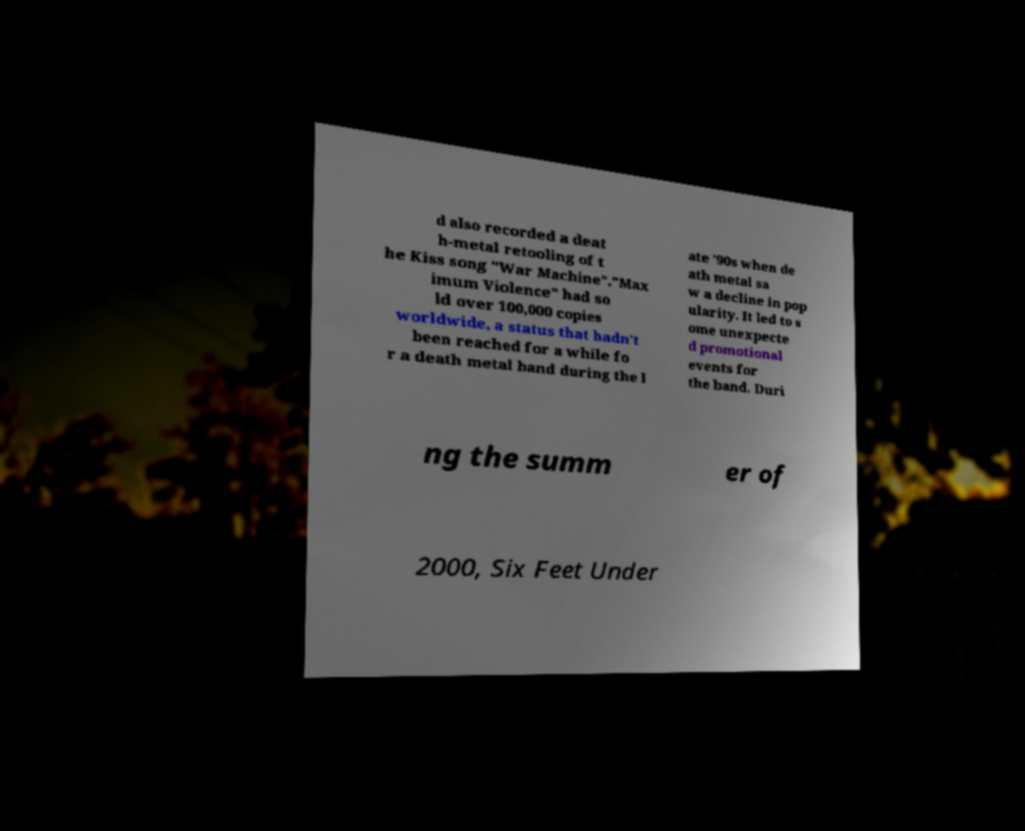What messages or text are displayed in this image? I need them in a readable, typed format. d also recorded a deat h-metal retooling of t he Kiss song "War Machine"."Max imum Violence" had so ld over 100,000 copies worldwide, a status that hadn't been reached for a while fo r a death metal band during the l ate '90s when de ath metal sa w a decline in pop ularity. It led to s ome unexpecte d promotional events for the band. Duri ng the summ er of 2000, Six Feet Under 